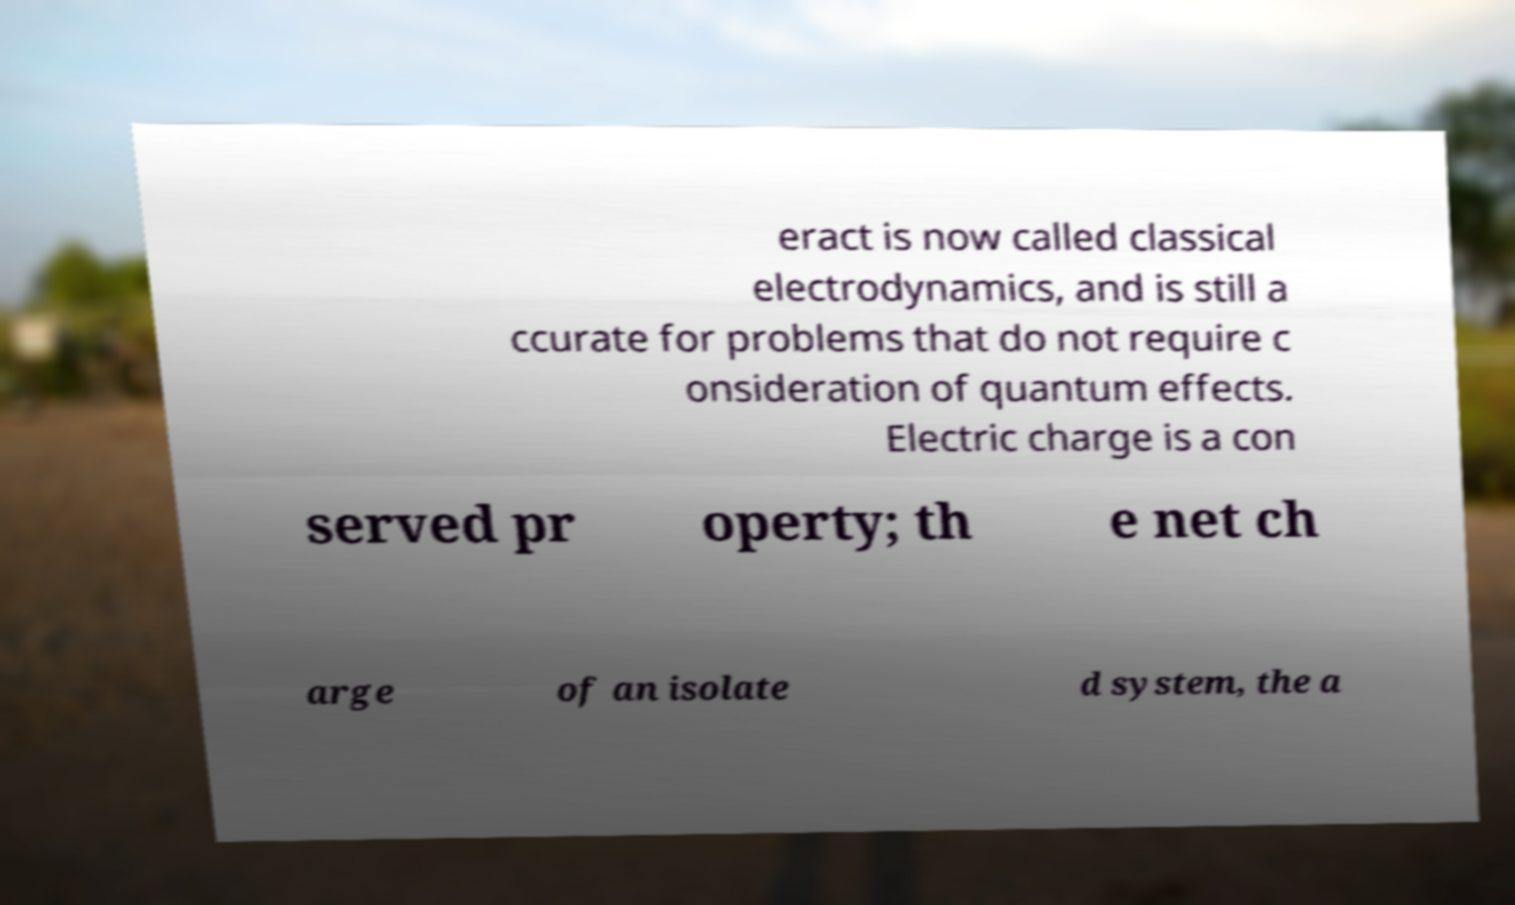Can you read and provide the text displayed in the image?This photo seems to have some interesting text. Can you extract and type it out for me? eract is now called classical electrodynamics, and is still a ccurate for problems that do not require c onsideration of quantum effects. Electric charge is a con served pr operty; th e net ch arge of an isolate d system, the a 